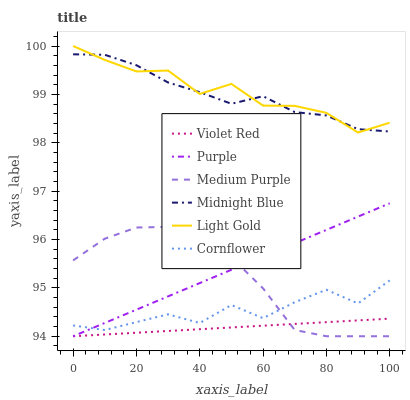Does Violet Red have the minimum area under the curve?
Answer yes or no. Yes. Does Light Gold have the maximum area under the curve?
Answer yes or no. Yes. Does Midnight Blue have the minimum area under the curve?
Answer yes or no. No. Does Midnight Blue have the maximum area under the curve?
Answer yes or no. No. Is Purple the smoothest?
Answer yes or no. Yes. Is Cornflower the roughest?
Answer yes or no. Yes. Is Violet Red the smoothest?
Answer yes or no. No. Is Violet Red the roughest?
Answer yes or no. No. Does Violet Red have the lowest value?
Answer yes or no. Yes. Does Midnight Blue have the lowest value?
Answer yes or no. No. Does Light Gold have the highest value?
Answer yes or no. Yes. Does Midnight Blue have the highest value?
Answer yes or no. No. Is Cornflower less than Light Gold?
Answer yes or no. Yes. Is Midnight Blue greater than Medium Purple?
Answer yes or no. Yes. Does Purple intersect Cornflower?
Answer yes or no. Yes. Is Purple less than Cornflower?
Answer yes or no. No. Is Purple greater than Cornflower?
Answer yes or no. No. Does Cornflower intersect Light Gold?
Answer yes or no. No. 